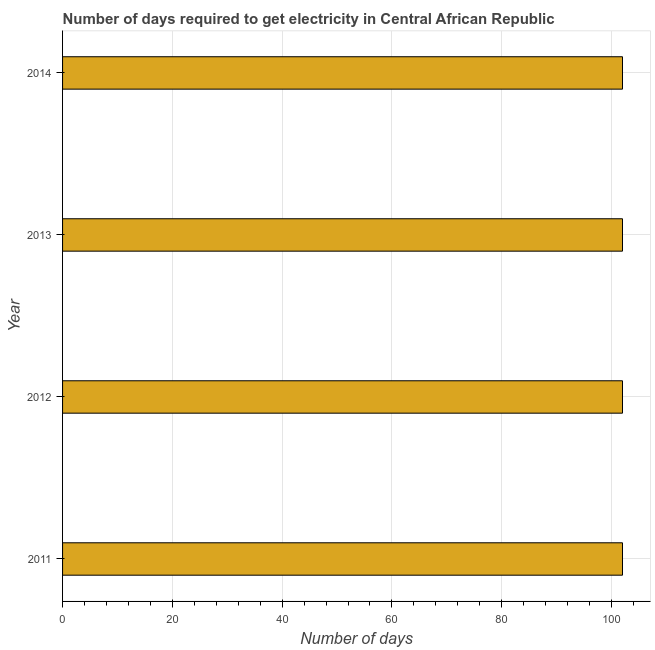Does the graph contain any zero values?
Your response must be concise. No. What is the title of the graph?
Give a very brief answer. Number of days required to get electricity in Central African Republic. What is the label or title of the X-axis?
Your answer should be very brief. Number of days. What is the time to get electricity in 2013?
Ensure brevity in your answer.  102. Across all years, what is the maximum time to get electricity?
Provide a short and direct response. 102. Across all years, what is the minimum time to get electricity?
Provide a succinct answer. 102. In which year was the time to get electricity maximum?
Keep it short and to the point. 2011. What is the sum of the time to get electricity?
Ensure brevity in your answer.  408. What is the average time to get electricity per year?
Your response must be concise. 102. What is the median time to get electricity?
Provide a succinct answer. 102. What is the difference between the highest and the second highest time to get electricity?
Provide a succinct answer. 0. Is the sum of the time to get electricity in 2012 and 2013 greater than the maximum time to get electricity across all years?
Provide a succinct answer. Yes. What is the difference between the highest and the lowest time to get electricity?
Make the answer very short. 0. How many bars are there?
Offer a very short reply. 4. How many years are there in the graph?
Offer a very short reply. 4. What is the difference between two consecutive major ticks on the X-axis?
Offer a terse response. 20. Are the values on the major ticks of X-axis written in scientific E-notation?
Ensure brevity in your answer.  No. What is the Number of days of 2011?
Your answer should be compact. 102. What is the Number of days of 2012?
Give a very brief answer. 102. What is the Number of days of 2013?
Provide a short and direct response. 102. What is the Number of days of 2014?
Provide a succinct answer. 102. What is the difference between the Number of days in 2011 and 2012?
Offer a terse response. 0. What is the difference between the Number of days in 2011 and 2014?
Keep it short and to the point. 0. What is the difference between the Number of days in 2012 and 2013?
Offer a very short reply. 0. What is the difference between the Number of days in 2012 and 2014?
Your response must be concise. 0. What is the difference between the Number of days in 2013 and 2014?
Your answer should be compact. 0. What is the ratio of the Number of days in 2011 to that in 2012?
Ensure brevity in your answer.  1. What is the ratio of the Number of days in 2011 to that in 2013?
Ensure brevity in your answer.  1. 